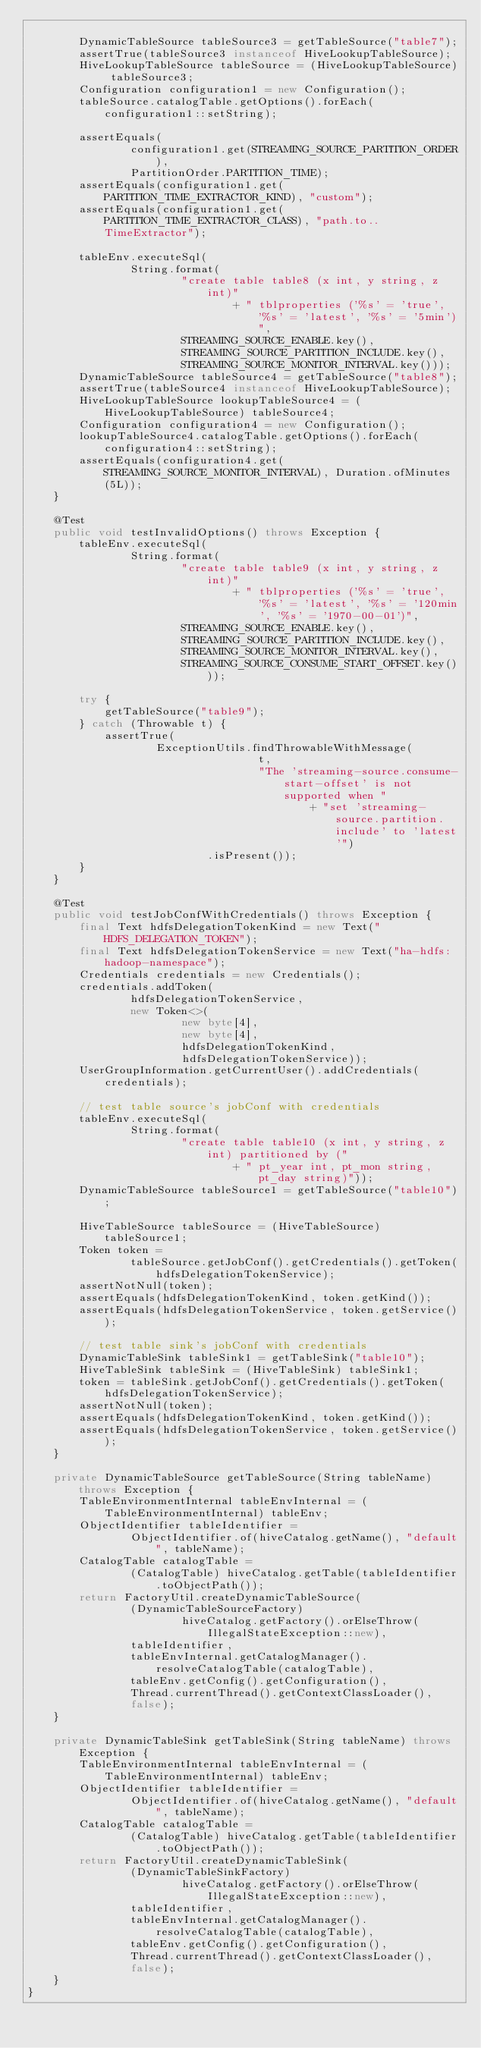Convert code to text. <code><loc_0><loc_0><loc_500><loc_500><_Java_>
        DynamicTableSource tableSource3 = getTableSource("table7");
        assertTrue(tableSource3 instanceof HiveLookupTableSource);
        HiveLookupTableSource tableSource = (HiveLookupTableSource) tableSource3;
        Configuration configuration1 = new Configuration();
        tableSource.catalogTable.getOptions().forEach(configuration1::setString);

        assertEquals(
                configuration1.get(STREAMING_SOURCE_PARTITION_ORDER),
                PartitionOrder.PARTITION_TIME);
        assertEquals(configuration1.get(PARTITION_TIME_EXTRACTOR_KIND), "custom");
        assertEquals(configuration1.get(PARTITION_TIME_EXTRACTOR_CLASS), "path.to..TimeExtractor");

        tableEnv.executeSql(
                String.format(
                        "create table table8 (x int, y string, z int)"
                                + " tblproperties ('%s' = 'true', '%s' = 'latest', '%s' = '5min')",
                        STREAMING_SOURCE_ENABLE.key(),
                        STREAMING_SOURCE_PARTITION_INCLUDE.key(),
                        STREAMING_SOURCE_MONITOR_INTERVAL.key()));
        DynamicTableSource tableSource4 = getTableSource("table8");
        assertTrue(tableSource4 instanceof HiveLookupTableSource);
        HiveLookupTableSource lookupTableSource4 = (HiveLookupTableSource) tableSource4;
        Configuration configuration4 = new Configuration();
        lookupTableSource4.catalogTable.getOptions().forEach(configuration4::setString);
        assertEquals(configuration4.get(STREAMING_SOURCE_MONITOR_INTERVAL), Duration.ofMinutes(5L));
    }

    @Test
    public void testInvalidOptions() throws Exception {
        tableEnv.executeSql(
                String.format(
                        "create table table9 (x int, y string, z int)"
                                + " tblproperties ('%s' = 'true', '%s' = 'latest', '%s' = '120min', '%s' = '1970-00-01')",
                        STREAMING_SOURCE_ENABLE.key(),
                        STREAMING_SOURCE_PARTITION_INCLUDE.key(),
                        STREAMING_SOURCE_MONITOR_INTERVAL.key(),
                        STREAMING_SOURCE_CONSUME_START_OFFSET.key()));

        try {
            getTableSource("table9");
        } catch (Throwable t) {
            assertTrue(
                    ExceptionUtils.findThrowableWithMessage(
                                    t,
                                    "The 'streaming-source.consume-start-offset' is not supported when "
                                            + "set 'streaming-source.partition.include' to 'latest'")
                            .isPresent());
        }
    }

    @Test
    public void testJobConfWithCredentials() throws Exception {
        final Text hdfsDelegationTokenKind = new Text("HDFS_DELEGATION_TOKEN");
        final Text hdfsDelegationTokenService = new Text("ha-hdfs:hadoop-namespace");
        Credentials credentials = new Credentials();
        credentials.addToken(
                hdfsDelegationTokenService,
                new Token<>(
                        new byte[4],
                        new byte[4],
                        hdfsDelegationTokenKind,
                        hdfsDelegationTokenService));
        UserGroupInformation.getCurrentUser().addCredentials(credentials);

        // test table source's jobConf with credentials
        tableEnv.executeSql(
                String.format(
                        "create table table10 (x int, y string, z int) partitioned by ("
                                + " pt_year int, pt_mon string, pt_day string)"));
        DynamicTableSource tableSource1 = getTableSource("table10");

        HiveTableSource tableSource = (HiveTableSource) tableSource1;
        Token token =
                tableSource.getJobConf().getCredentials().getToken(hdfsDelegationTokenService);
        assertNotNull(token);
        assertEquals(hdfsDelegationTokenKind, token.getKind());
        assertEquals(hdfsDelegationTokenService, token.getService());

        // test table sink's jobConf with credentials
        DynamicTableSink tableSink1 = getTableSink("table10");
        HiveTableSink tableSink = (HiveTableSink) tableSink1;
        token = tableSink.getJobConf().getCredentials().getToken(hdfsDelegationTokenService);
        assertNotNull(token);
        assertEquals(hdfsDelegationTokenKind, token.getKind());
        assertEquals(hdfsDelegationTokenService, token.getService());
    }

    private DynamicTableSource getTableSource(String tableName) throws Exception {
        TableEnvironmentInternal tableEnvInternal = (TableEnvironmentInternal) tableEnv;
        ObjectIdentifier tableIdentifier =
                ObjectIdentifier.of(hiveCatalog.getName(), "default", tableName);
        CatalogTable catalogTable =
                (CatalogTable) hiveCatalog.getTable(tableIdentifier.toObjectPath());
        return FactoryUtil.createDynamicTableSource(
                (DynamicTableSourceFactory)
                        hiveCatalog.getFactory().orElseThrow(IllegalStateException::new),
                tableIdentifier,
                tableEnvInternal.getCatalogManager().resolveCatalogTable(catalogTable),
                tableEnv.getConfig().getConfiguration(),
                Thread.currentThread().getContextClassLoader(),
                false);
    }

    private DynamicTableSink getTableSink(String tableName) throws Exception {
        TableEnvironmentInternal tableEnvInternal = (TableEnvironmentInternal) tableEnv;
        ObjectIdentifier tableIdentifier =
                ObjectIdentifier.of(hiveCatalog.getName(), "default", tableName);
        CatalogTable catalogTable =
                (CatalogTable) hiveCatalog.getTable(tableIdentifier.toObjectPath());
        return FactoryUtil.createDynamicTableSink(
                (DynamicTableSinkFactory)
                        hiveCatalog.getFactory().orElseThrow(IllegalStateException::new),
                tableIdentifier,
                tableEnvInternal.getCatalogManager().resolveCatalogTable(catalogTable),
                tableEnv.getConfig().getConfiguration(),
                Thread.currentThread().getContextClassLoader(),
                false);
    }
}
</code> 